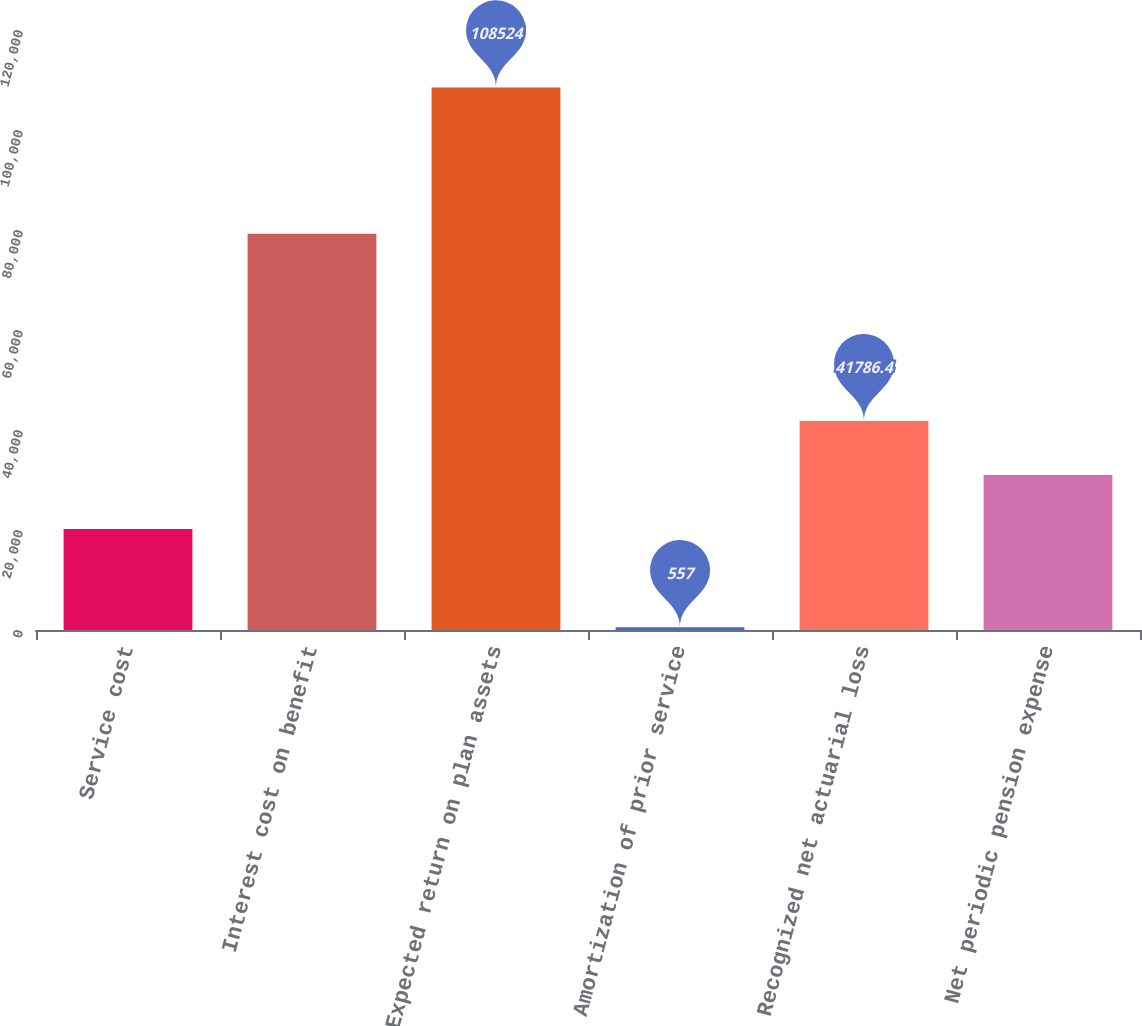Convert chart. <chart><loc_0><loc_0><loc_500><loc_500><bar_chart><fcel>Service cost<fcel>Interest cost on benefit<fcel>Expected return on plan assets<fcel>Amortization of prior service<fcel>Recognized net actuarial loss<fcel>Net periodic pension expense<nl><fcel>20193<fcel>79270<fcel>108524<fcel>557<fcel>41786.4<fcel>30989.7<nl></chart> 